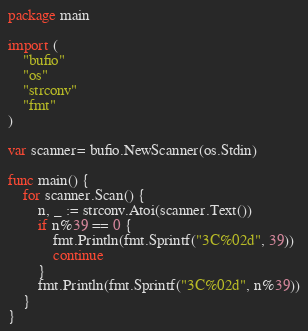Convert code to text. <code><loc_0><loc_0><loc_500><loc_500><_Go_>package main

import (
	"bufio"
	"os"
	"strconv"
	"fmt"
)

var scanner= bufio.NewScanner(os.Stdin)

func main() {
	for scanner.Scan() {
		n, _ := strconv.Atoi(scanner.Text())
		if n%39 == 0 {
			fmt.Println(fmt.Sprintf("3C%02d", 39))
			continue
		}
		fmt.Println(fmt.Sprintf("3C%02d", n%39))
	}
}
</code> 